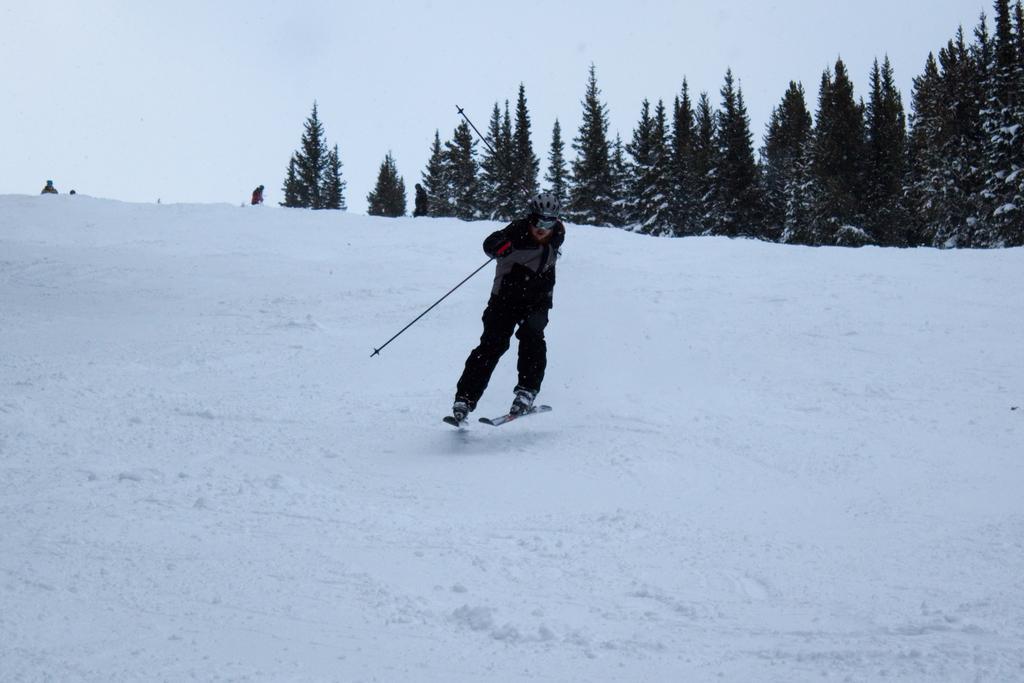Could you give a brief overview of what you see in this image? In this image I can see a person is on the ski board and holding sticks and wearing black,ash and red color dress. Back Side I can see a trees and snow. The sky is in white color. 